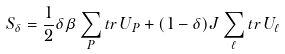<formula> <loc_0><loc_0><loc_500><loc_500>S _ { \delta } = \frac { 1 } { 2 } \delta \beta \sum _ { P } t r \, U _ { P } + ( 1 - \delta ) J \sum _ { \ell } t r \, U _ { \ell }</formula> 